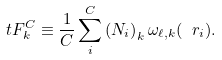Convert formula to latex. <formula><loc_0><loc_0><loc_500><loc_500>\ t F _ { k } ^ { C } \equiv \frac { 1 } { C } \sum _ { i } ^ { C } \left ( N _ { i } \right ) _ { k } \omega _ { \ell , k } ( \ r _ { i } ) .</formula> 